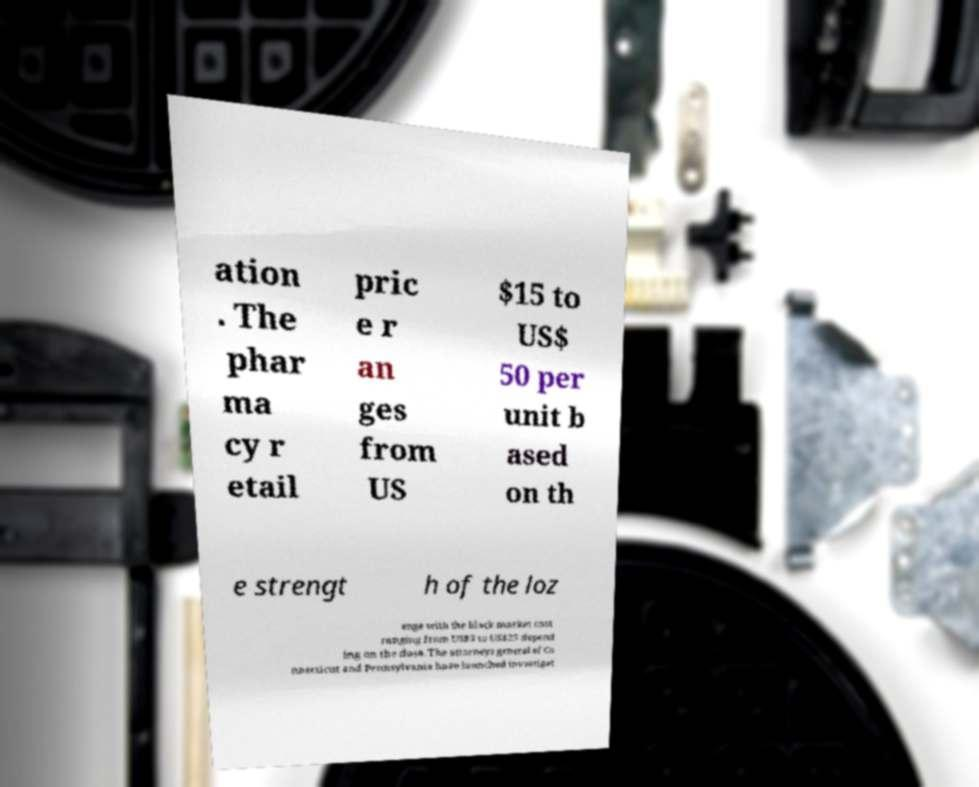What messages or text are displayed in this image? I need them in a readable, typed format. ation . The phar ma cy r etail pric e r an ges from US $15 to US$ 50 per unit b ased on th e strengt h of the loz enge with the black market cost ranging from US$5 to US$25 depend ing on the dose. The attorneys general of Co nnecticut and Pennsylvania have launched investigat 